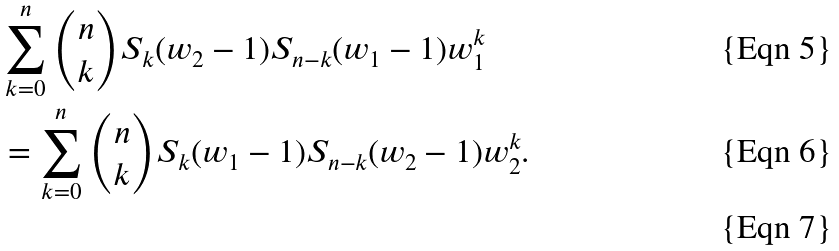Convert formula to latex. <formula><loc_0><loc_0><loc_500><loc_500>& \sum _ { k = 0 } ^ { n } \binom { n } { k } S _ { k } ( w _ { 2 } - 1 ) S _ { n - k } ( w _ { 1 } - 1 ) w _ { 1 } ^ { k } \\ & = \sum _ { k = 0 } ^ { n } \binom { n } { k } S _ { k } ( w _ { 1 } - 1 ) S _ { n - k } ( w _ { 2 } - 1 ) w _ { 2 } ^ { k } . \\</formula> 